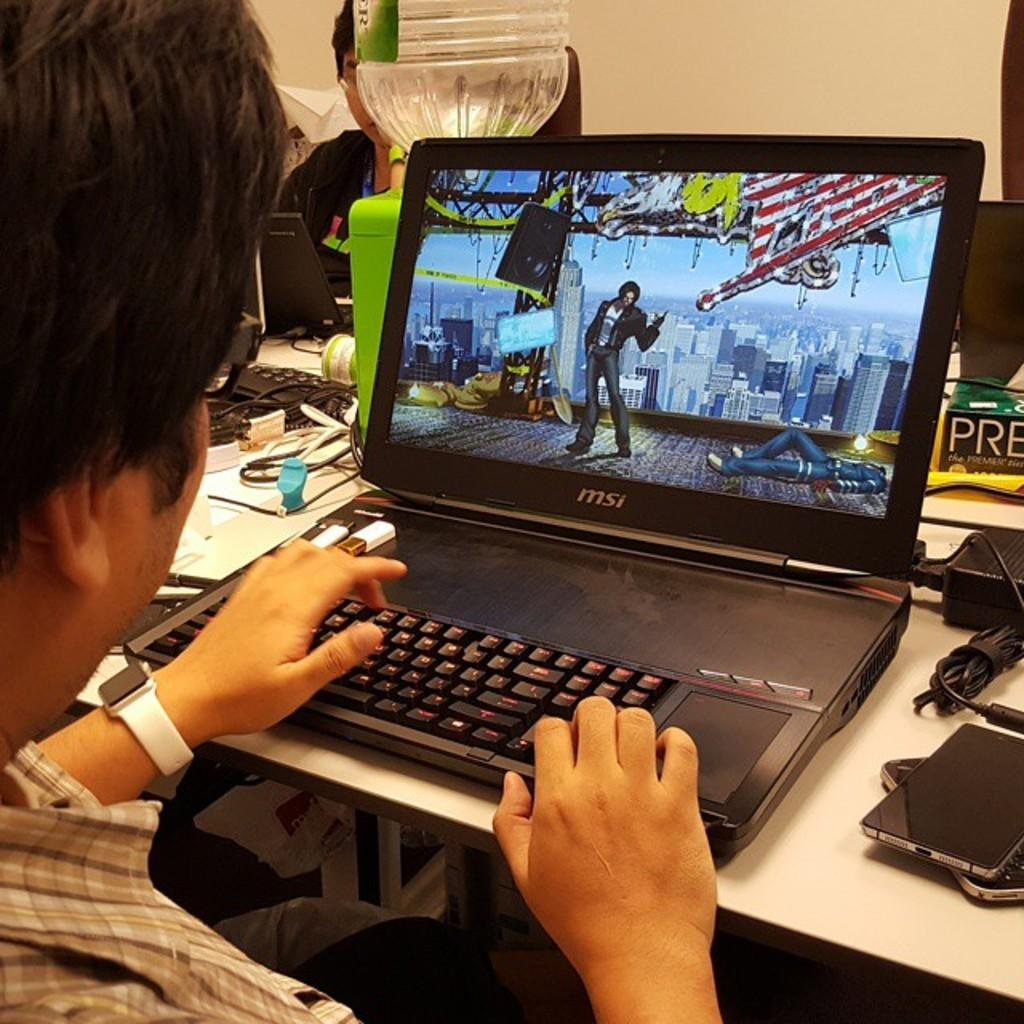<image>
Give a short and clear explanation of the subsequent image. A man is working on a MSI black laptop. 